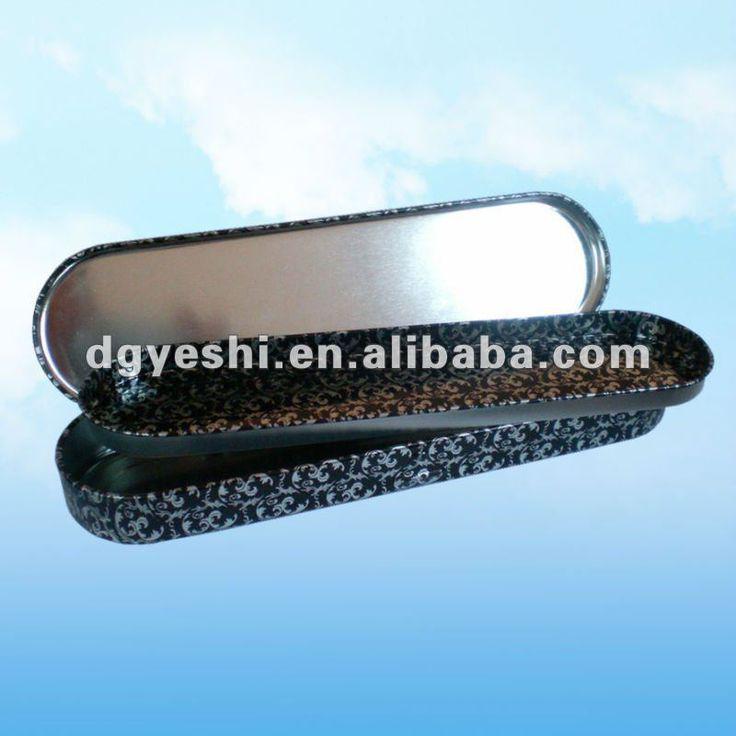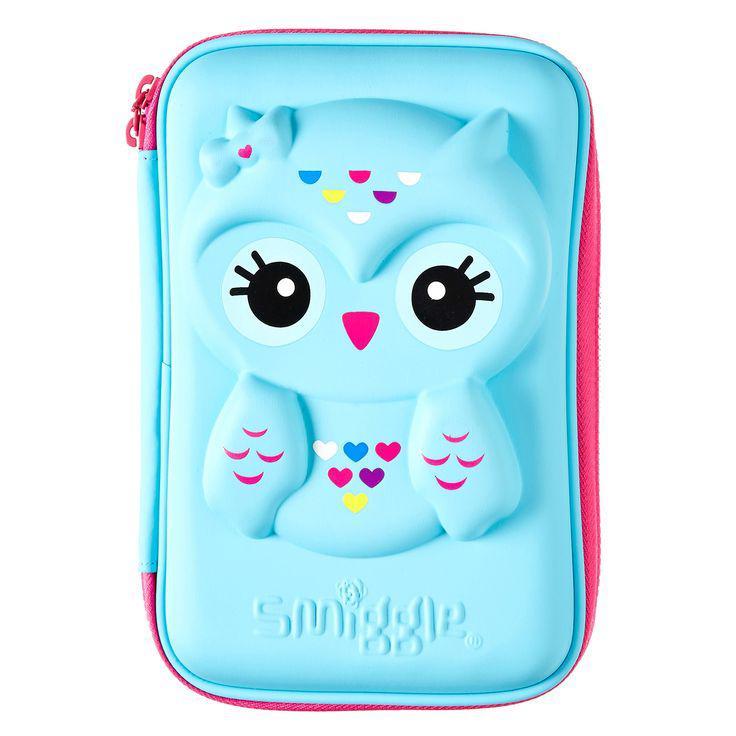The first image is the image on the left, the second image is the image on the right. Examine the images to the left and right. Is the description "There is 1 pencil case that is fully open displaying pencils and pens." accurate? Answer yes or no. No. The first image is the image on the left, the second image is the image on the right. For the images shown, is this caption "The image to the left features exactly one case, and it is open." true? Answer yes or no. Yes. 